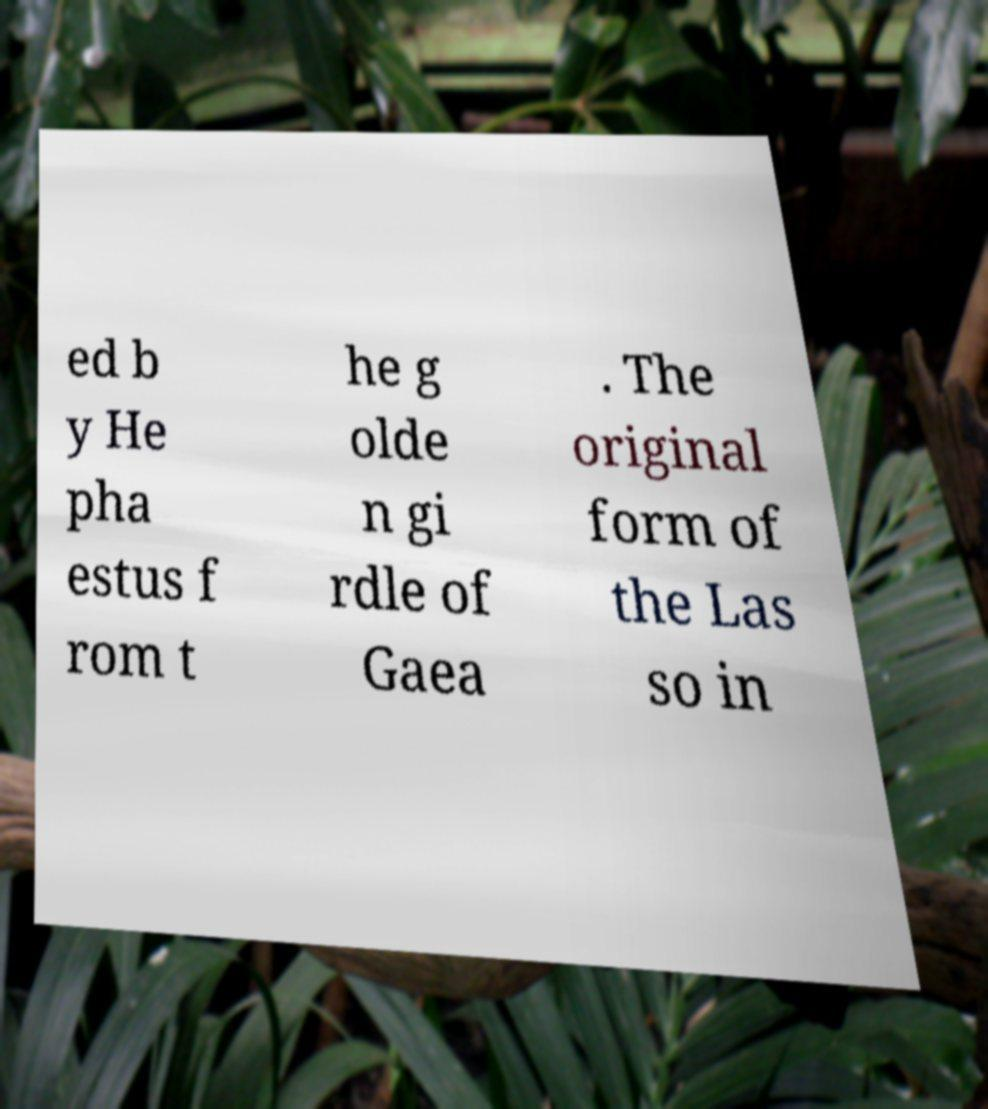Please identify and transcribe the text found in this image. ed b y He pha estus f rom t he g olde n gi rdle of Gaea . The original form of the Las so in 